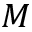<formula> <loc_0><loc_0><loc_500><loc_500>M</formula> 